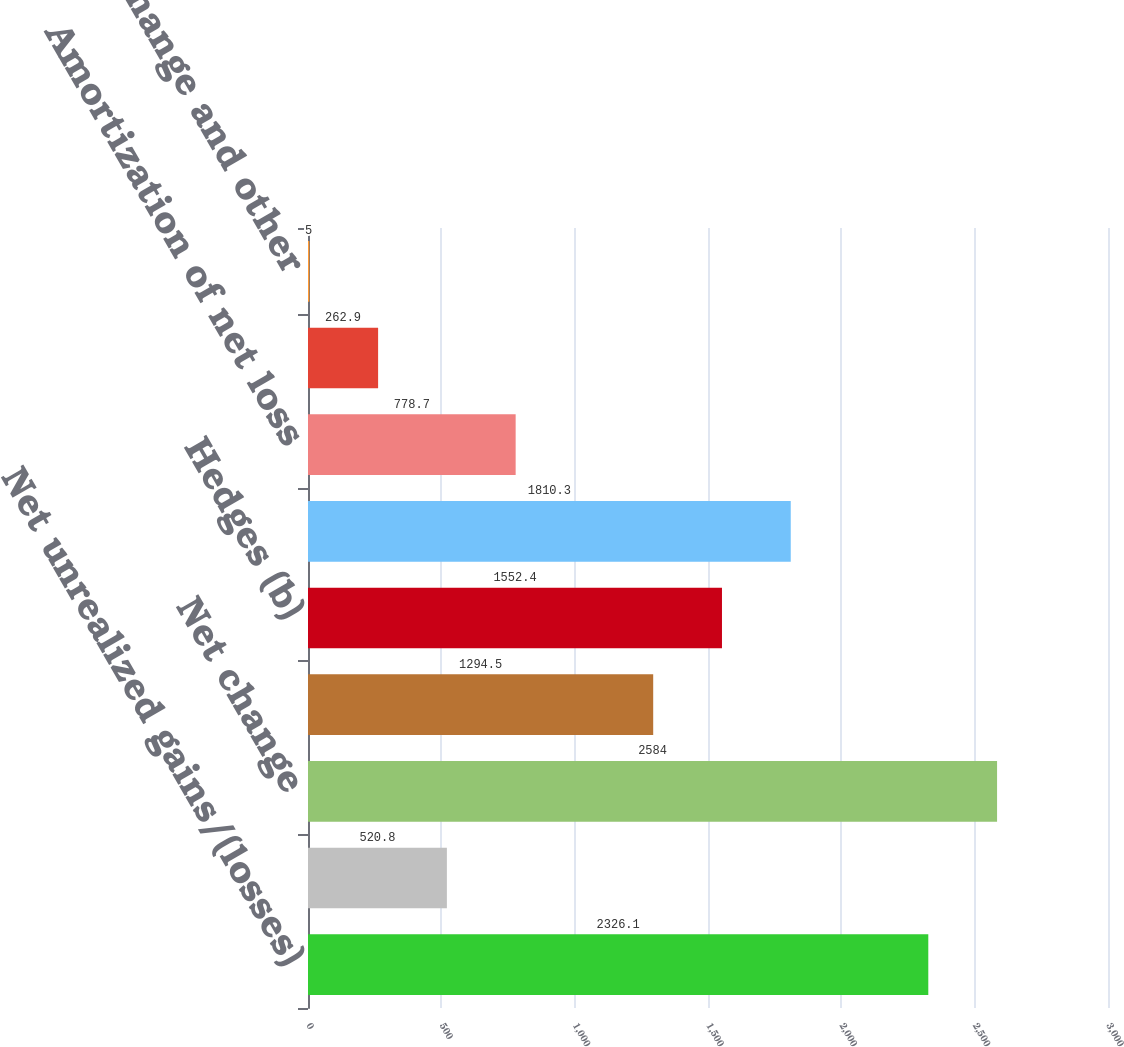Convert chart to OTSL. <chart><loc_0><loc_0><loc_500><loc_500><bar_chart><fcel>Net unrealized gains/(losses)<fcel>Reclassification adjustment<fcel>Net change<fcel>Translation (b)<fcel>Hedges (b)<fcel>Net gains/(losses) arising<fcel>Amortization of net loss<fcel>Prior service costs/(credits)<fcel>Foreign exchange and other<nl><fcel>2326.1<fcel>520.8<fcel>2584<fcel>1294.5<fcel>1552.4<fcel>1810.3<fcel>778.7<fcel>262.9<fcel>5<nl></chart> 